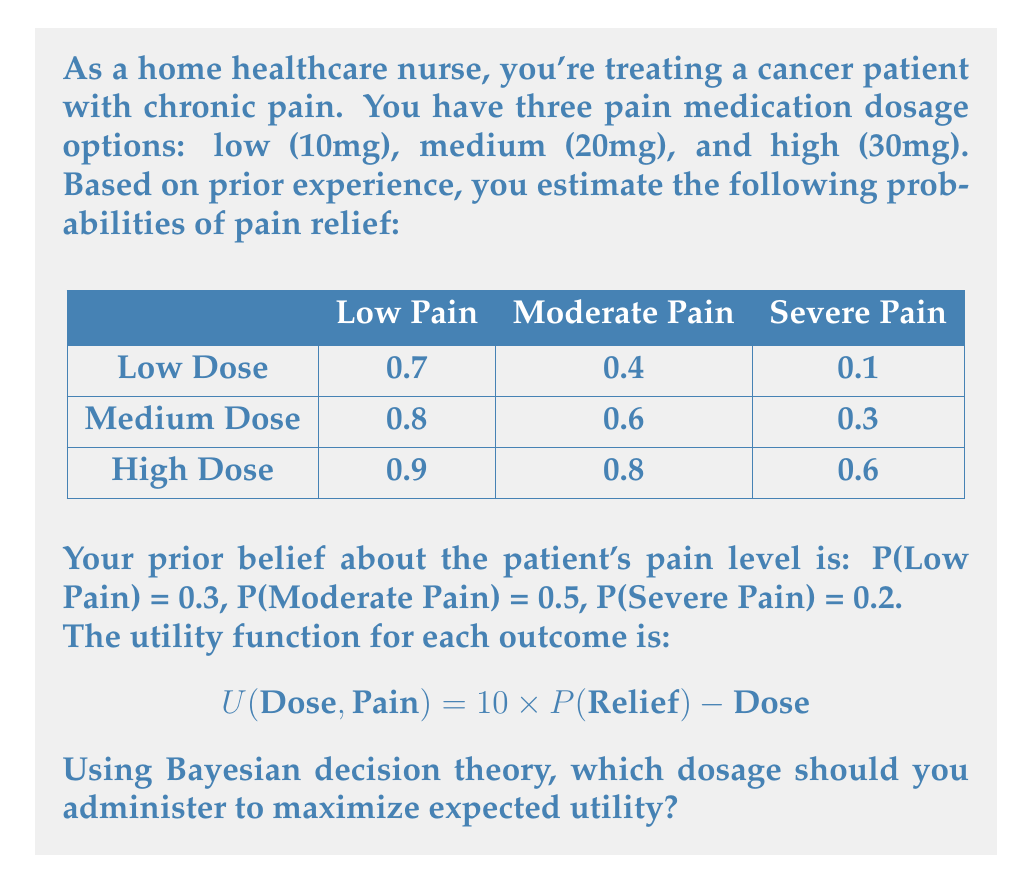Help me with this question. To solve this problem using Bayesian decision theory, we need to calculate the expected utility for each dosage option and choose the one with the highest value. Here's the step-by-step process:

1) First, let's calculate the expected utility for each dosage:

   $E[U(\text{Dose})] = \sum_{i} P(\text{Pain}_i) \times U(\text{Dose}, \text{Pain}_i)$

2) For Low Dose (10mg):
   $E[U(\text{Low})] = 0.3 \times (10 \times 0.7 - 10) + 0.5 \times (10 \times 0.4 - 10) + 0.2 \times (10 \times 0.1 - 10)$
   $= 0.3 \times (-3) + 0.5 \times (-6) + 0.2 \times (-9)$
   $= -0.9 - 3 - 1.8 = -5.7$

3) For Medium Dose (20mg):
   $E[U(\text{Medium})] = 0.3 \times (10 \times 0.8 - 20) + 0.5 \times (10 \times 0.6 - 20) + 0.2 \times (10 \times 0.3 - 20)$
   $= 0.3 \times (-12) + 0.5 \times (-14) + 0.2 \times (-17)$
   $= -3.6 - 7 - 3.4 = -14$

4) For High Dose (30mg):
   $E[U(\text{High})] = 0.3 \times (10 \times 0.9 - 30) + 0.5 \times (10 \times 0.8 - 30) + 0.2 \times (10 \times 0.6 - 30)$
   $= 0.3 \times (-21) + 0.5 \times (-22) + 0.2 \times (-24)$
   $= -6.3 - 11 - 4.8 = -22.1$

5) Compare the expected utilities:
   Low Dose: -5.7
   Medium Dose: -14
   High Dose: -22.1

The highest expected utility is -5.7, corresponding to the Low Dose option.
Answer: Low Dose (10mg) 